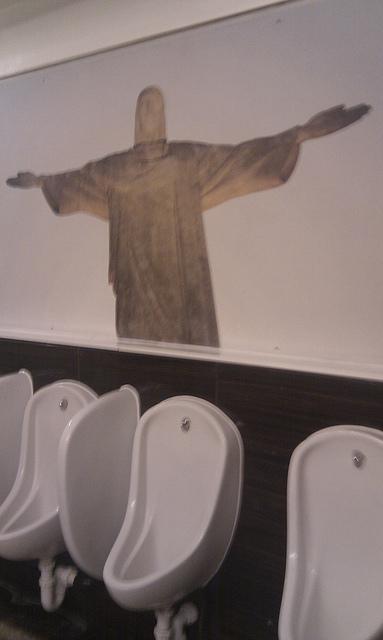Is this a normal artwork for the room?
Give a very brief answer. No. Is this a restroom for ladies?
Keep it brief. No. Is there a divider between urinals?
Keep it brief. Yes. 